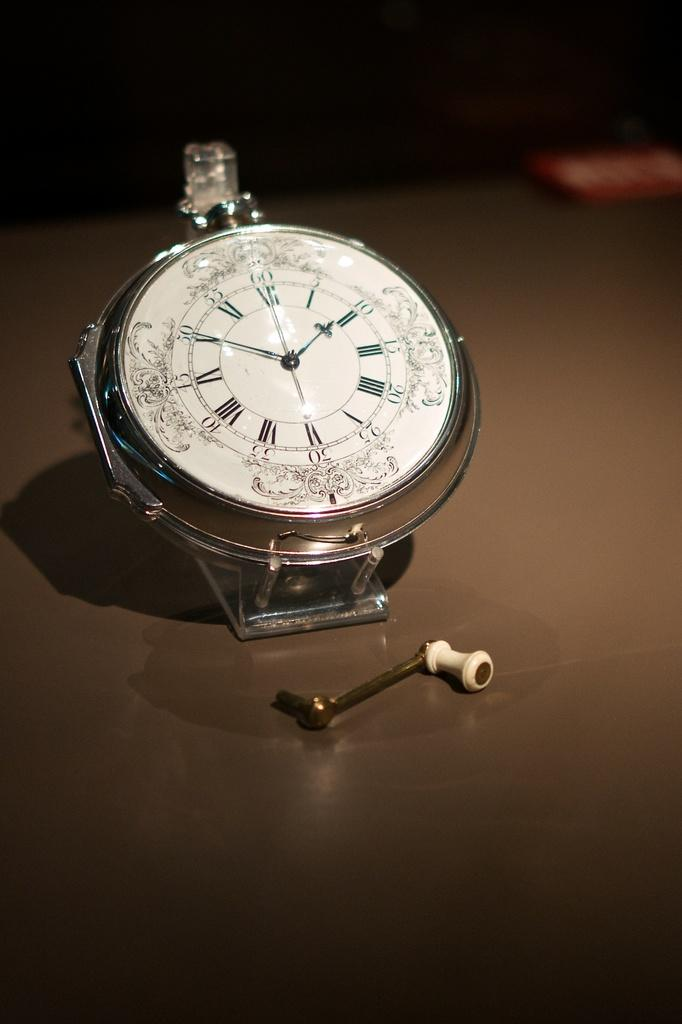What is the main subject of the image? The main subject of the image is a watch dial. Are there any other objects visible on the surface in the image? Yes, there is another object on the surface in the image. How would you describe the background of the image? The background of the image is blurry. What scientific position does the watch dial hold in the image? The image does not depict a scientific position or context, so this question cannot be answered. 